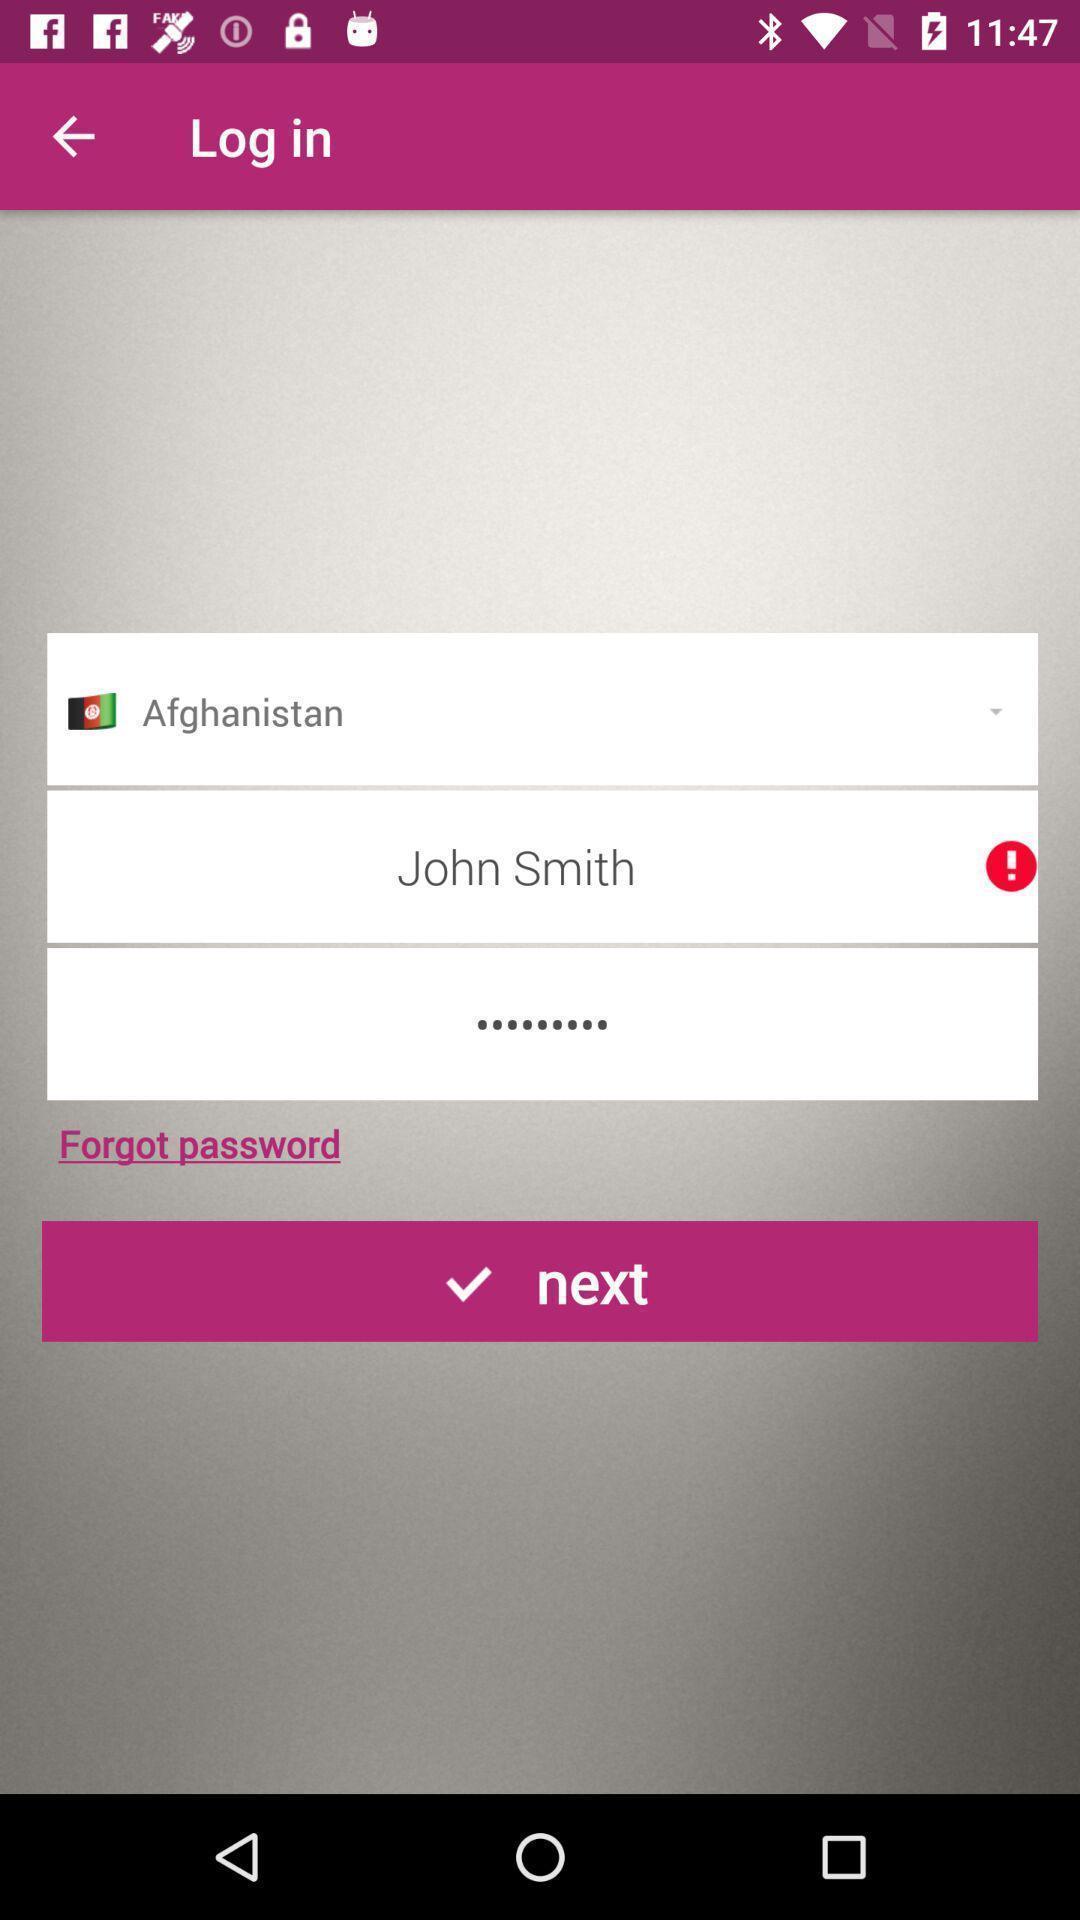Tell me what you see in this picture. Screen shows login details. 